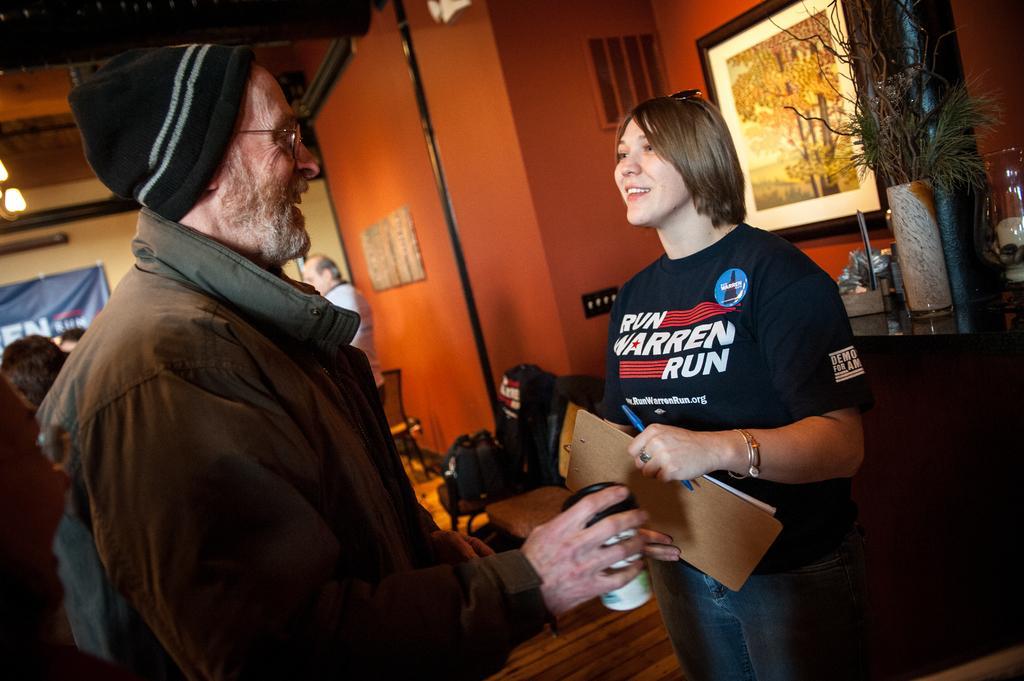In one or two sentences, can you explain what this image depicts? In this image, we can see an old man is holding glass and wearing cap, glasses. Here a woman is standing and holding pad, pen and smiling. Background there is a wall, photo frame, some objects, banner. Here we can see few people, bags, table few objects are placed on it. At the bottom, there is a wooden floor. 